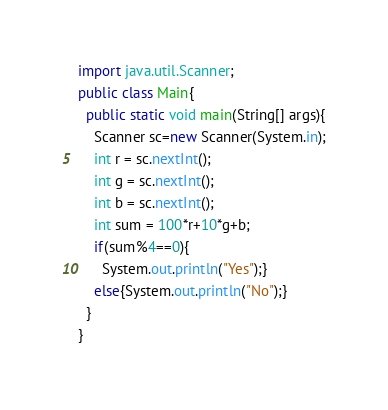Convert code to text. <code><loc_0><loc_0><loc_500><loc_500><_Java_>import java.util.Scanner;
public class Main{
  public static void main(String[] args){
    Scanner sc=new Scanner(System.in);
    int r = sc.nextInt();
    int g = sc.nextInt();
    int b = sc.nextInt();
    int sum = 100*r+10*g+b;
    if(sum%4==0){
      System.out.println("Yes");}
    else{System.out.println("No");}
  }
}
</code> 